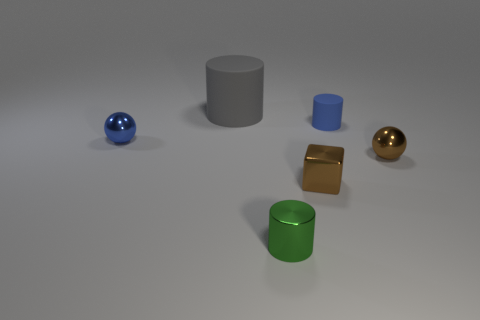Is there any other thing that is the same size as the gray rubber object?
Offer a terse response. No. What size is the ball that is the same color as the small matte object?
Provide a short and direct response. Small. Are there any small green shiny objects of the same shape as the small rubber object?
Ensure brevity in your answer.  Yes. There is another cylinder that is the same size as the metal cylinder; what is its color?
Keep it short and to the point. Blue. Are there fewer tiny blue rubber things in front of the brown metal cube than shiny balls left of the large cylinder?
Give a very brief answer. Yes. Does the sphere behind the brown shiny ball have the same size as the blue rubber cylinder?
Ensure brevity in your answer.  Yes. What is the shape of the shiny thing that is right of the small brown cube?
Your response must be concise. Sphere. Are there more tiny blue shiny things than cyan balls?
Make the answer very short. Yes. There is a metal sphere left of the small brown sphere; does it have the same color as the tiny metal cylinder?
Provide a short and direct response. No. What number of things are small shiny objects that are left of the tiny green object or tiny objects on the right side of the green metallic cylinder?
Offer a very short reply. 4. 